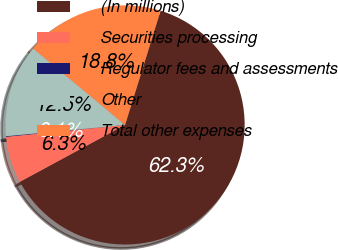Convert chart to OTSL. <chart><loc_0><loc_0><loc_500><loc_500><pie_chart><fcel>(In millions)<fcel>Securities processing<fcel>Regulator fees and assessments<fcel>Other<fcel>Total other expenses<nl><fcel>62.3%<fcel>6.31%<fcel>0.09%<fcel>12.53%<fcel>18.76%<nl></chart> 